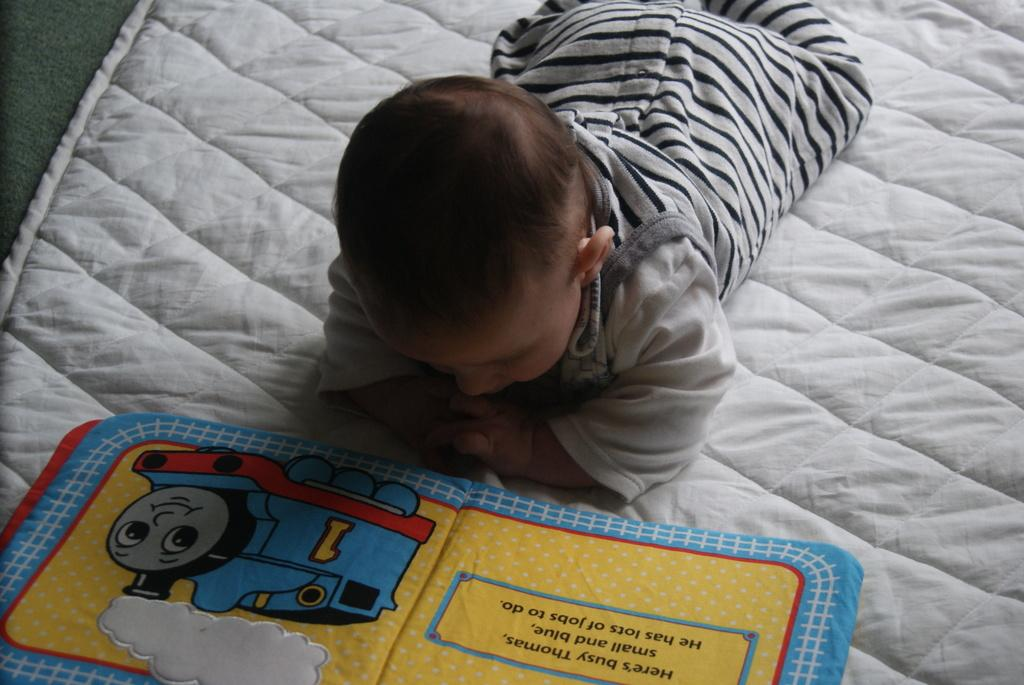What is the main subject of the image? The main subject of the image is a kid. What is the kid doing in the image? The kid is lying on a bed. What is the kid looking at or interacting with in the image? The kid is looking into a book. What type of thread is being used by the kid to communicate with the waves in the image? There is no thread, communication, or waves present in the image. The kid is simply looking into a book while lying on a bed. 